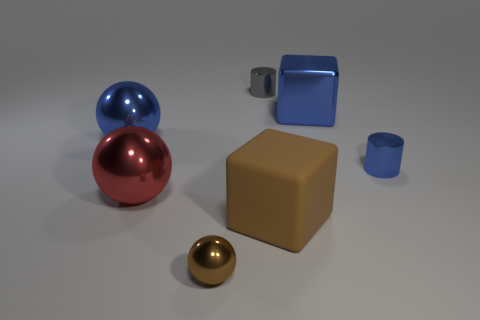Add 3 big red matte objects. How many objects exist? 10 Subtract all big blue spheres. How many spheres are left? 2 Subtract all cyan spheres. Subtract all green blocks. How many spheres are left? 3 Subtract all spheres. How many objects are left? 4 Add 2 blue things. How many blue things exist? 5 Subtract 0 gray blocks. How many objects are left? 7 Subtract all large blue metal cylinders. Subtract all brown cubes. How many objects are left? 6 Add 2 tiny balls. How many tiny balls are left? 3 